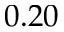<formula> <loc_0><loc_0><loc_500><loc_500>0 . 2 0</formula> 